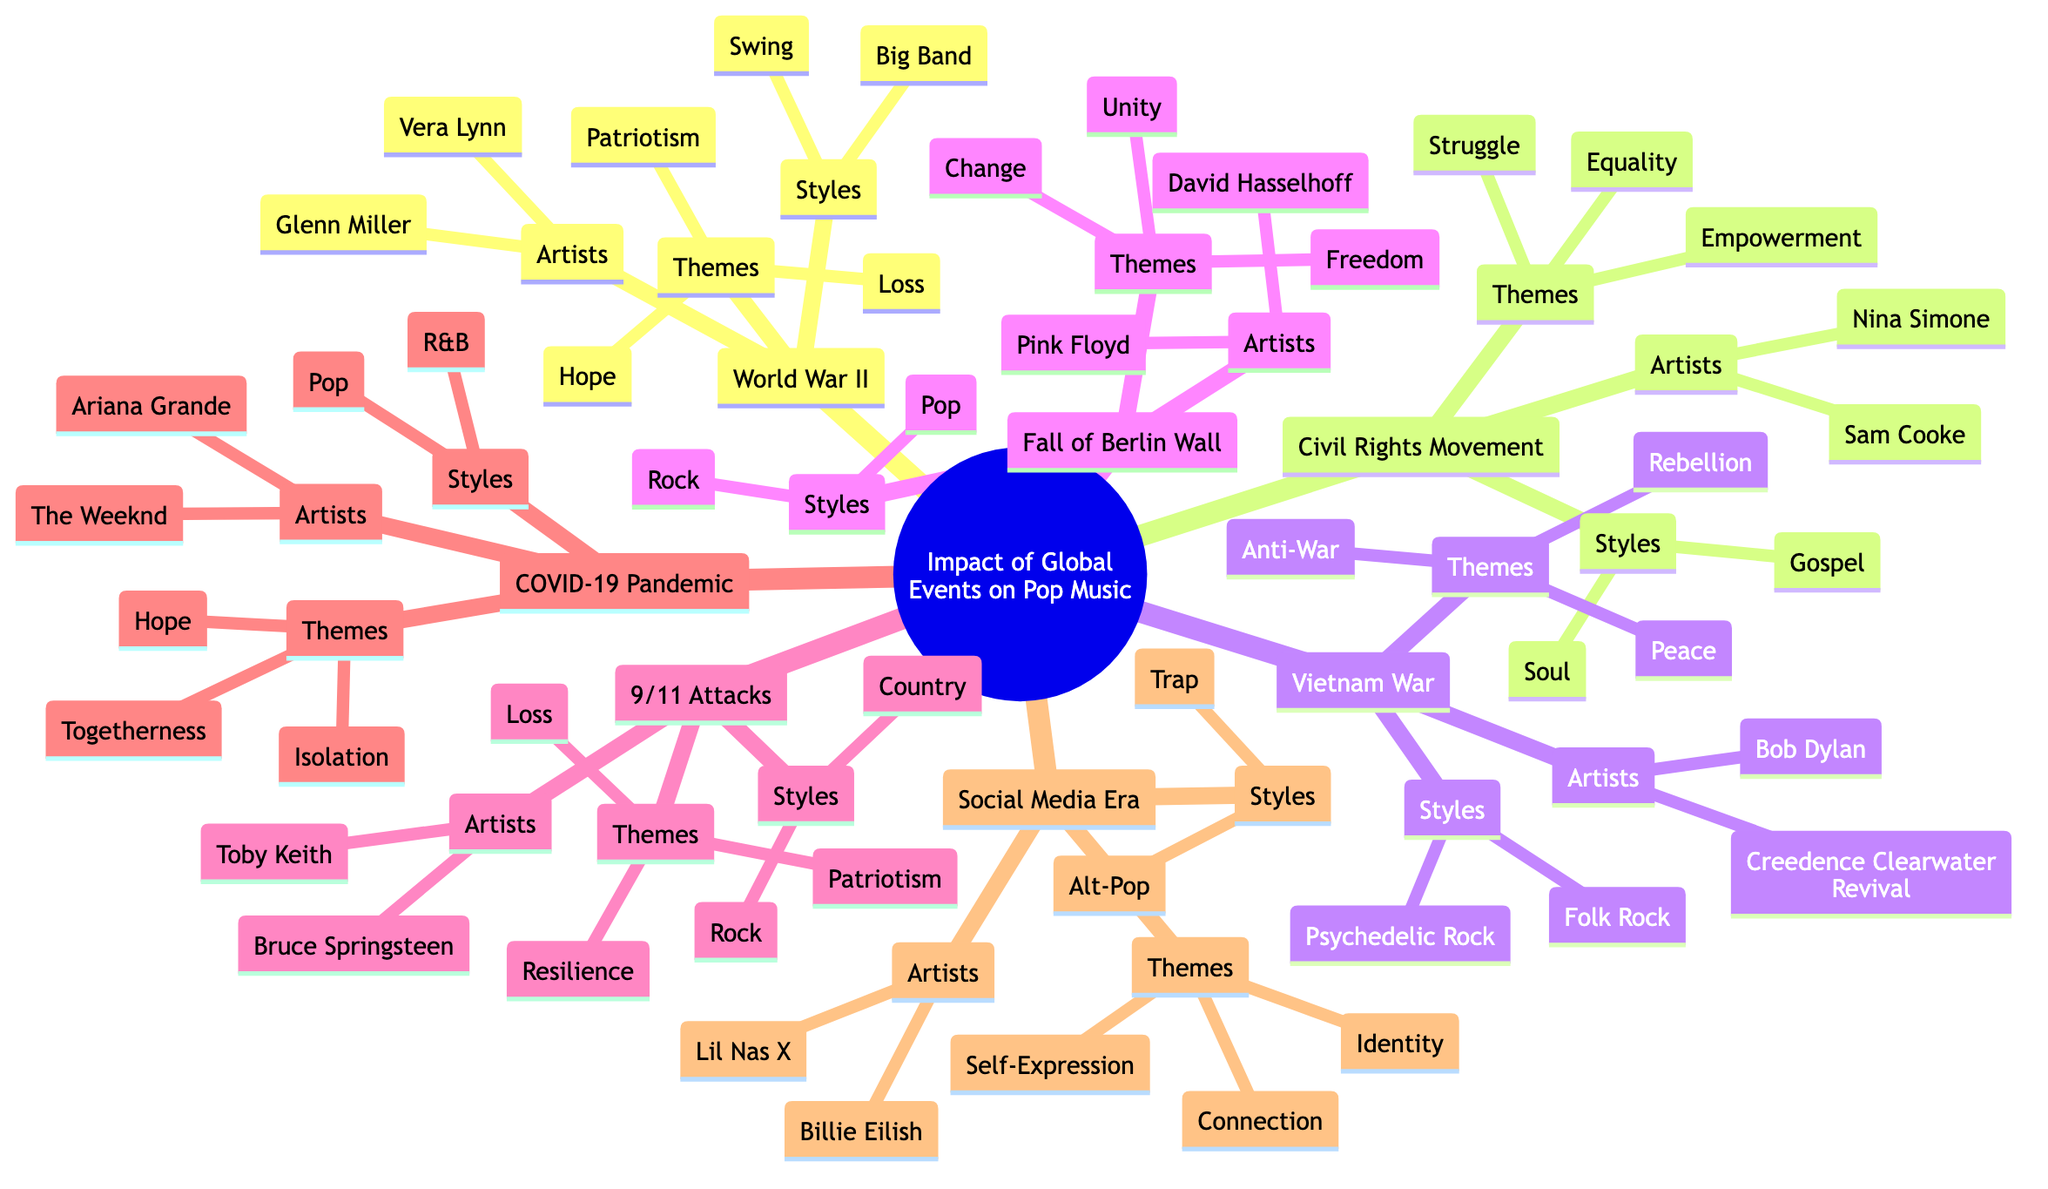What are the main themes associated with the Vietnam War? The Vietnam War node lists the themes: Anti-War, Peace, and Rebellion. These themes can be directly found under the Vietnam War node in the diagram.
Answer: Anti-War, Peace, Rebellion Which two artists are associated with the social media era? By looking at the Social Media Era node, the artists listed are Billie Eilish and Lil Nas X. This information is straightforward from the diagram.
Answer: Billie Eilish, Lil Nas X How many themes are listed under the Civil Rights Movement? The Civil Rights Movement node shows three themes: Equality, Empowerment, and Struggle. Counting them gives a total of three.
Answer: 3 What style of music is associated with Bruce Springsteen? The 9/11 Terrorist Attacks node lists Bruce Springsteen as one of the artists and shows the styles associated with this event as Country and Rock. Thus, Bruce Springsteen is associated with these styles.
Answer: Country, Rock Which two themes are common in both World War II and the 9/11 Terrorist Attacks? Looking at the themes under both World War II (Patriotism, Hope, Loss) and the 9/11 Terrorist Attacks (Resilience, Patriotism, Loss), Patriotism and Loss are common in both categories.
Answer: Patriotism, Loss How does the style of music change from the Vietnam War to the COVID-19 Pandemic? The Vietnam War's styles are Folk Rock and Psychedelic Rock, while the COVID-19 Pandemic has Pop and R&B. The change shows a shift from Folk and Psychedelic styles to more contemporary styles of Pop and R&B.
Answer: From Folk Rock and Psychedelic Rock to Pop and R&B What is the significance of the Fall of the Berlin Wall in terms of pop music themes? The Fall of the Berlin Wall node includes themes such as Freedom, Unity, and Change, which highlight its significance as a pivotal transition point for both political and cultural expressions reflected in pop music.
Answer: Freedom, Unity, Change How many artists are listed under the COVID-19 Pandemic? The COVID-19 Pandemic node lists two artists: The Weeknd and Ariana Grande. This can be directly counted from the information in that section of the diagram.
Answer: 2 What music styles emerged from the Civil Rights Movement? Looking under the Civil Rights Movement, the styles noted are Soul and Gospel. This information can be found directly under that node in the diagram.
Answer: Soul, Gospel 